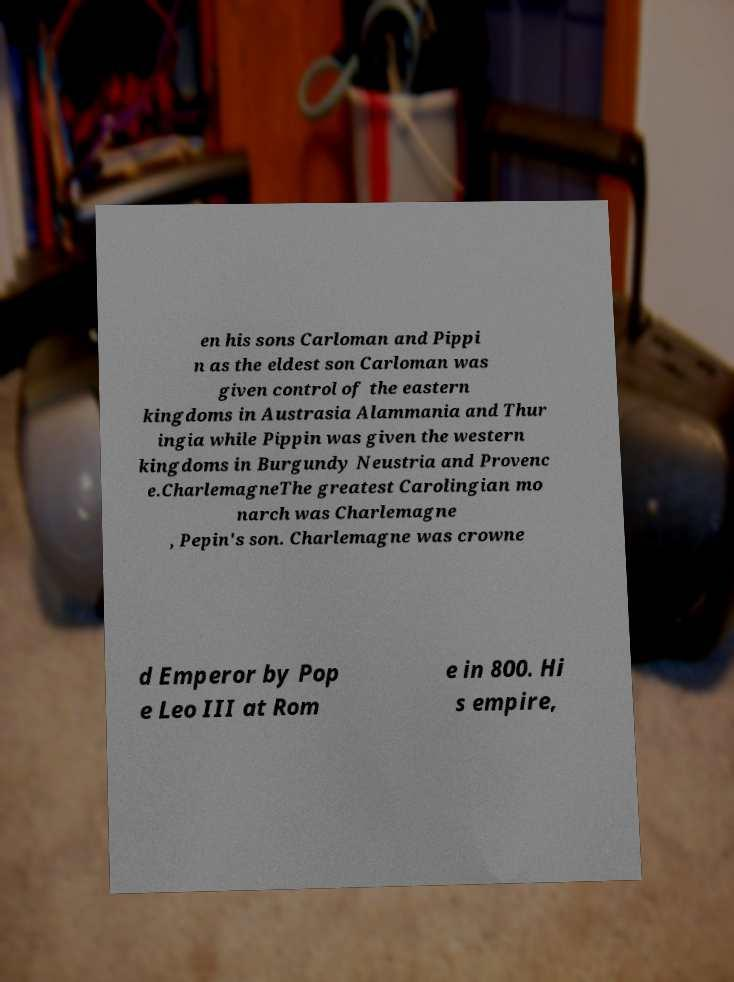Can you read and provide the text displayed in the image?This photo seems to have some interesting text. Can you extract and type it out for me? en his sons Carloman and Pippi n as the eldest son Carloman was given control of the eastern kingdoms in Austrasia Alammania and Thur ingia while Pippin was given the western kingdoms in Burgundy Neustria and Provenc e.CharlemagneThe greatest Carolingian mo narch was Charlemagne , Pepin's son. Charlemagne was crowne d Emperor by Pop e Leo III at Rom e in 800. Hi s empire, 